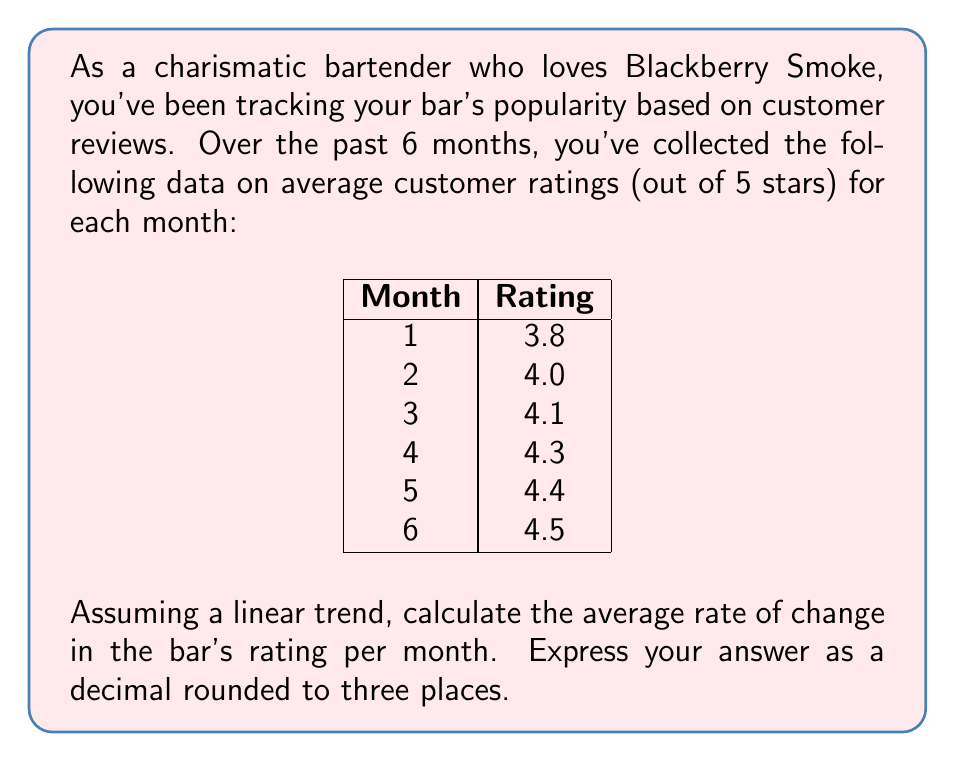Can you solve this math problem? To calculate the average rate of change, we'll use the formula:

$$\text{Average rate of change} = \frac{\text{Change in y}}{\text{Change in x}}$$

Where y represents the rating and x represents the month.

1. Identify the first and last data points:
   - First point: (1, 3.8)
   - Last point: (6, 4.5)

2. Calculate the change in y (rating):
   $$\Delta y = 4.5 - 3.8 = 0.7$$

3. Calculate the change in x (months):
   $$\Delta x = 6 - 1 = 5$$

4. Apply the formula:
   $$\text{Average rate of change} = \frac{\Delta y}{\Delta x} = \frac{0.7}{5} = 0.14$$

5. Round to three decimal places:
   $$0.140$$

This means that, on average, the bar's rating increases by 0.140 stars per month.
Answer: 0.140 stars per month 